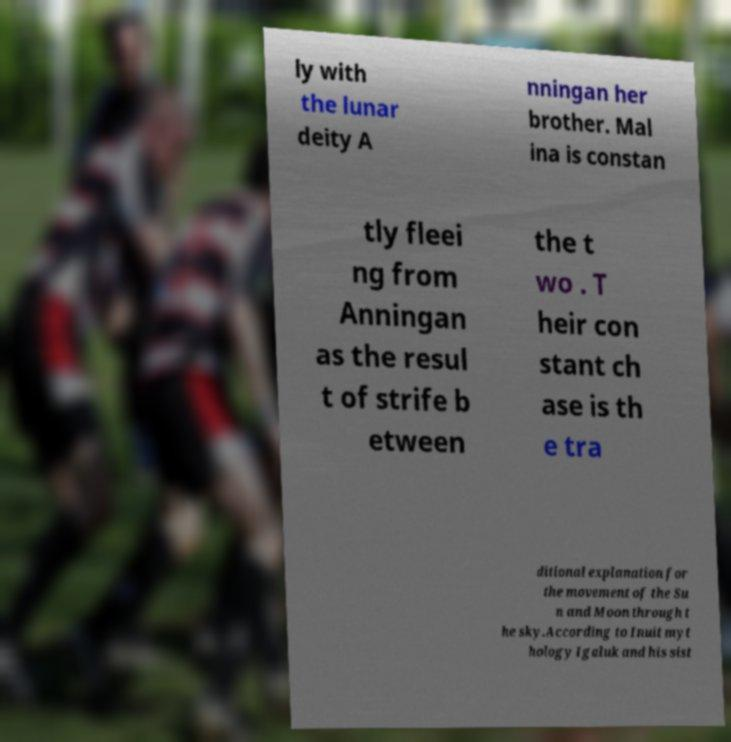Could you extract and type out the text from this image? ly with the lunar deity A nningan her brother. Mal ina is constan tly fleei ng from Anningan as the resul t of strife b etween the t wo . T heir con stant ch ase is th e tra ditional explanation for the movement of the Su n and Moon through t he sky.According to Inuit myt hology Igaluk and his sist 